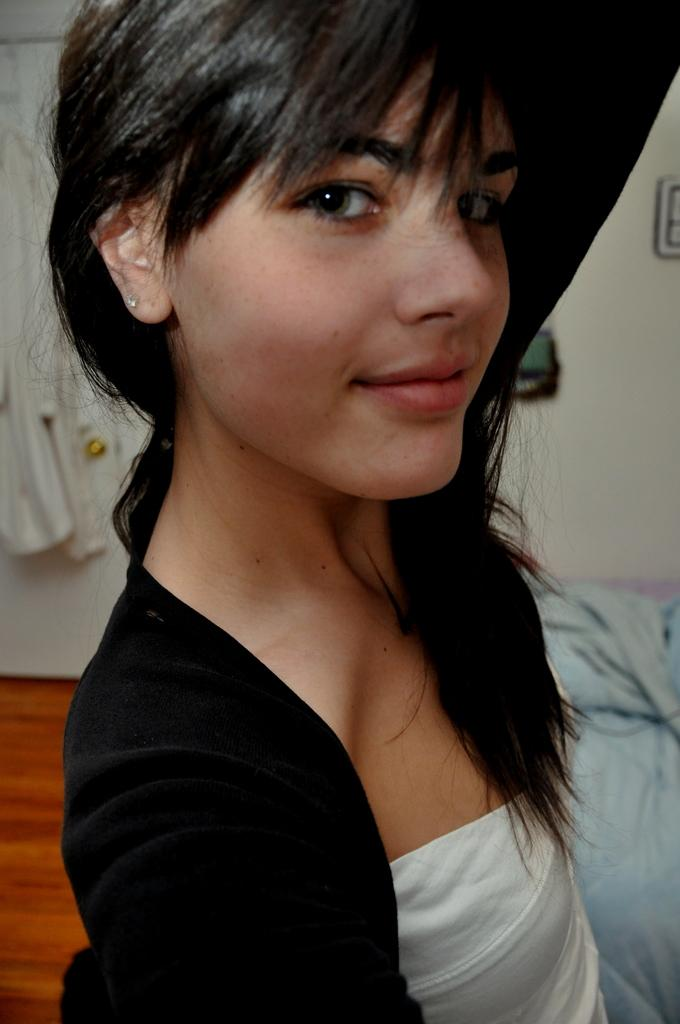What is the person in the image wearing? The person in the image is wearing a black and white dress. What color is the blanket visible in the background? The blanket in the background is blue. What type of structure can be seen in the background? There is a wall in the background. What architectural feature is present in the background? There is a door in the background. What other objects can be seen in the background? There are other objects visible in the background. Is the person in the image using a rake to clean the area? There is no rake present in the image, so it cannot be determined if the person is using one to clean the area. 